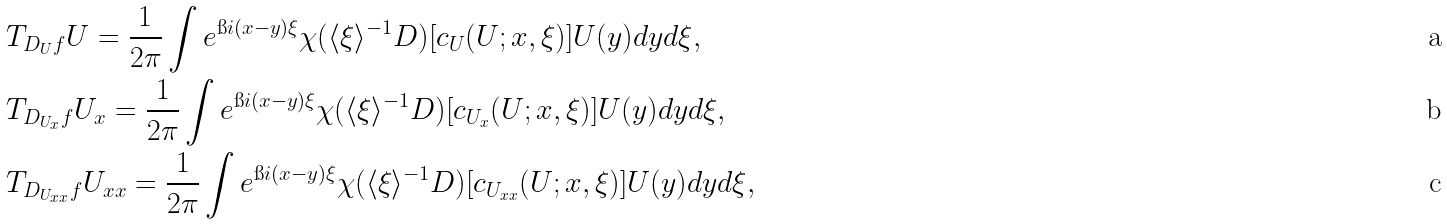Convert formula to latex. <formula><loc_0><loc_0><loc_500><loc_500>& T _ { D _ { U } f } U = \frac { 1 } { 2 \pi } \int e ^ { \i i ( x - y ) \xi } \chi ( \langle \xi \rangle ^ { - 1 } D ) [ c _ { U } ( U ; x , \xi ) ] U ( y ) d y d \xi , \\ & T _ { D _ { U _ { x } } f } U _ { x } = \frac { 1 } { 2 \pi } \int e ^ { \i i ( x - y ) \xi } \chi ( \langle \xi \rangle ^ { - 1 } D ) [ c _ { U _ { x } } ( U ; x , \xi ) ] U ( y ) d y d \xi , \\ & T _ { D _ { U _ { x x } } f } U _ { x x } = \frac { 1 } { 2 \pi } \int e ^ { \i i ( x - y ) \xi } \chi ( \langle \xi \rangle ^ { - 1 } D ) [ c _ { U _ { x x } } ( U ; x , \xi ) ] U ( y ) d y d \xi ,</formula> 